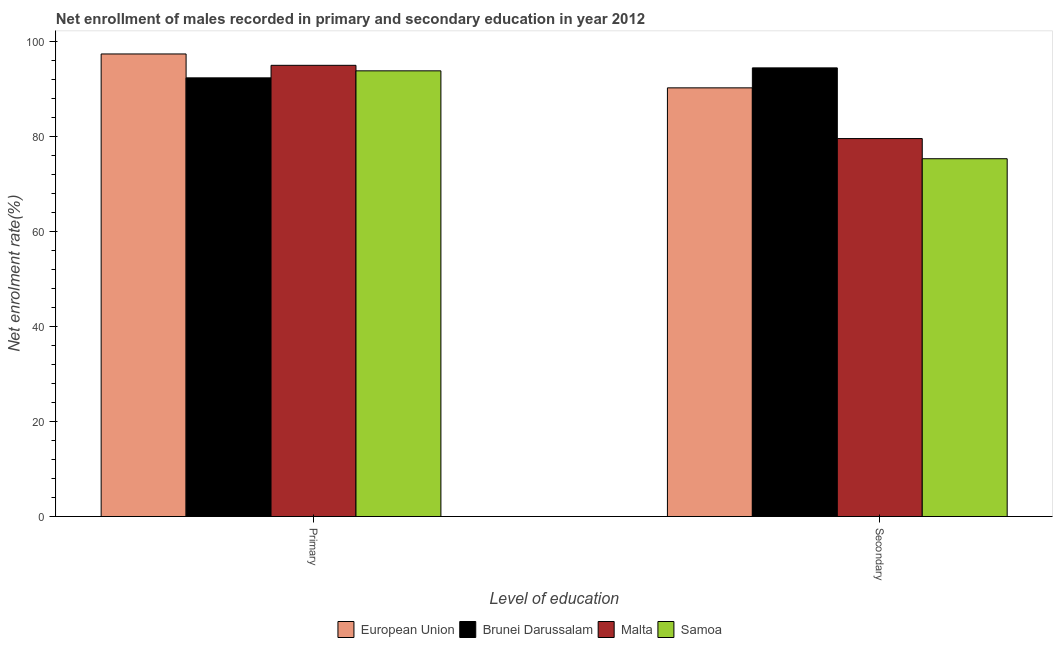How many different coloured bars are there?
Your answer should be compact. 4. How many groups of bars are there?
Your answer should be very brief. 2. Are the number of bars on each tick of the X-axis equal?
Your answer should be very brief. Yes. What is the label of the 2nd group of bars from the left?
Offer a terse response. Secondary. What is the enrollment rate in secondary education in European Union?
Provide a succinct answer. 90.28. Across all countries, what is the maximum enrollment rate in secondary education?
Provide a short and direct response. 94.49. Across all countries, what is the minimum enrollment rate in primary education?
Your answer should be compact. 92.39. In which country was the enrollment rate in primary education maximum?
Your answer should be very brief. European Union. In which country was the enrollment rate in primary education minimum?
Give a very brief answer. Brunei Darussalam. What is the total enrollment rate in primary education in the graph?
Ensure brevity in your answer.  378.71. What is the difference between the enrollment rate in primary education in Samoa and that in Malta?
Make the answer very short. -1.16. What is the difference between the enrollment rate in secondary education in Malta and the enrollment rate in primary education in Samoa?
Make the answer very short. -14.27. What is the average enrollment rate in primary education per country?
Your answer should be very brief. 94.68. What is the difference between the enrollment rate in primary education and enrollment rate in secondary education in Brunei Darussalam?
Ensure brevity in your answer.  -2.1. In how many countries, is the enrollment rate in primary education greater than 60 %?
Keep it short and to the point. 4. What is the ratio of the enrollment rate in secondary education in Samoa to that in Malta?
Keep it short and to the point. 0.95. Is the enrollment rate in primary education in European Union less than that in Malta?
Your answer should be compact. No. In how many countries, is the enrollment rate in secondary education greater than the average enrollment rate in secondary education taken over all countries?
Offer a very short reply. 2. What is the difference between two consecutive major ticks on the Y-axis?
Your answer should be compact. 20. Are the values on the major ticks of Y-axis written in scientific E-notation?
Your answer should be very brief. No. Does the graph contain grids?
Provide a succinct answer. No. What is the title of the graph?
Give a very brief answer. Net enrollment of males recorded in primary and secondary education in year 2012. What is the label or title of the X-axis?
Offer a terse response. Level of education. What is the label or title of the Y-axis?
Keep it short and to the point. Net enrolment rate(%). What is the Net enrolment rate(%) of European Union in Primary?
Keep it short and to the point. 97.42. What is the Net enrolment rate(%) in Brunei Darussalam in Primary?
Ensure brevity in your answer.  92.39. What is the Net enrolment rate(%) in Malta in Primary?
Offer a very short reply. 95.03. What is the Net enrolment rate(%) in Samoa in Primary?
Provide a succinct answer. 93.87. What is the Net enrolment rate(%) in European Union in Secondary?
Offer a very short reply. 90.28. What is the Net enrolment rate(%) of Brunei Darussalam in Secondary?
Your answer should be compact. 94.49. What is the Net enrolment rate(%) in Malta in Secondary?
Your answer should be compact. 79.6. What is the Net enrolment rate(%) in Samoa in Secondary?
Offer a very short reply. 75.36. Across all Level of education, what is the maximum Net enrolment rate(%) in European Union?
Provide a succinct answer. 97.42. Across all Level of education, what is the maximum Net enrolment rate(%) in Brunei Darussalam?
Keep it short and to the point. 94.49. Across all Level of education, what is the maximum Net enrolment rate(%) of Malta?
Provide a short and direct response. 95.03. Across all Level of education, what is the maximum Net enrolment rate(%) of Samoa?
Your response must be concise. 93.87. Across all Level of education, what is the minimum Net enrolment rate(%) in European Union?
Give a very brief answer. 90.28. Across all Level of education, what is the minimum Net enrolment rate(%) of Brunei Darussalam?
Make the answer very short. 92.39. Across all Level of education, what is the minimum Net enrolment rate(%) of Malta?
Provide a succinct answer. 79.6. Across all Level of education, what is the minimum Net enrolment rate(%) of Samoa?
Offer a very short reply. 75.36. What is the total Net enrolment rate(%) in European Union in the graph?
Keep it short and to the point. 187.71. What is the total Net enrolment rate(%) of Brunei Darussalam in the graph?
Your answer should be compact. 186.88. What is the total Net enrolment rate(%) in Malta in the graph?
Ensure brevity in your answer.  174.63. What is the total Net enrolment rate(%) in Samoa in the graph?
Your answer should be compact. 169.22. What is the difference between the Net enrolment rate(%) of European Union in Primary and that in Secondary?
Keep it short and to the point. 7.14. What is the difference between the Net enrolment rate(%) of Brunei Darussalam in Primary and that in Secondary?
Offer a terse response. -2.1. What is the difference between the Net enrolment rate(%) in Malta in Primary and that in Secondary?
Give a very brief answer. 15.43. What is the difference between the Net enrolment rate(%) of Samoa in Primary and that in Secondary?
Provide a short and direct response. 18.51. What is the difference between the Net enrolment rate(%) in European Union in Primary and the Net enrolment rate(%) in Brunei Darussalam in Secondary?
Provide a succinct answer. 2.93. What is the difference between the Net enrolment rate(%) in European Union in Primary and the Net enrolment rate(%) in Malta in Secondary?
Make the answer very short. 17.82. What is the difference between the Net enrolment rate(%) in European Union in Primary and the Net enrolment rate(%) in Samoa in Secondary?
Ensure brevity in your answer.  22.07. What is the difference between the Net enrolment rate(%) of Brunei Darussalam in Primary and the Net enrolment rate(%) of Malta in Secondary?
Offer a terse response. 12.79. What is the difference between the Net enrolment rate(%) of Brunei Darussalam in Primary and the Net enrolment rate(%) of Samoa in Secondary?
Your response must be concise. 17.03. What is the difference between the Net enrolment rate(%) in Malta in Primary and the Net enrolment rate(%) in Samoa in Secondary?
Your answer should be compact. 19.67. What is the average Net enrolment rate(%) in European Union per Level of education?
Provide a succinct answer. 93.85. What is the average Net enrolment rate(%) of Brunei Darussalam per Level of education?
Your answer should be compact. 93.44. What is the average Net enrolment rate(%) of Malta per Level of education?
Make the answer very short. 87.32. What is the average Net enrolment rate(%) in Samoa per Level of education?
Your answer should be compact. 84.61. What is the difference between the Net enrolment rate(%) of European Union and Net enrolment rate(%) of Brunei Darussalam in Primary?
Give a very brief answer. 5.03. What is the difference between the Net enrolment rate(%) in European Union and Net enrolment rate(%) in Malta in Primary?
Offer a terse response. 2.39. What is the difference between the Net enrolment rate(%) of European Union and Net enrolment rate(%) of Samoa in Primary?
Ensure brevity in your answer.  3.56. What is the difference between the Net enrolment rate(%) of Brunei Darussalam and Net enrolment rate(%) of Malta in Primary?
Make the answer very short. -2.64. What is the difference between the Net enrolment rate(%) of Brunei Darussalam and Net enrolment rate(%) of Samoa in Primary?
Provide a succinct answer. -1.48. What is the difference between the Net enrolment rate(%) in Malta and Net enrolment rate(%) in Samoa in Primary?
Ensure brevity in your answer.  1.16. What is the difference between the Net enrolment rate(%) in European Union and Net enrolment rate(%) in Brunei Darussalam in Secondary?
Your response must be concise. -4.21. What is the difference between the Net enrolment rate(%) in European Union and Net enrolment rate(%) in Malta in Secondary?
Keep it short and to the point. 10.68. What is the difference between the Net enrolment rate(%) of European Union and Net enrolment rate(%) of Samoa in Secondary?
Your answer should be compact. 14.93. What is the difference between the Net enrolment rate(%) in Brunei Darussalam and Net enrolment rate(%) in Malta in Secondary?
Your answer should be compact. 14.89. What is the difference between the Net enrolment rate(%) in Brunei Darussalam and Net enrolment rate(%) in Samoa in Secondary?
Provide a short and direct response. 19.13. What is the difference between the Net enrolment rate(%) in Malta and Net enrolment rate(%) in Samoa in Secondary?
Your answer should be very brief. 4.25. What is the ratio of the Net enrolment rate(%) of European Union in Primary to that in Secondary?
Provide a short and direct response. 1.08. What is the ratio of the Net enrolment rate(%) of Brunei Darussalam in Primary to that in Secondary?
Ensure brevity in your answer.  0.98. What is the ratio of the Net enrolment rate(%) in Malta in Primary to that in Secondary?
Your answer should be very brief. 1.19. What is the ratio of the Net enrolment rate(%) of Samoa in Primary to that in Secondary?
Ensure brevity in your answer.  1.25. What is the difference between the highest and the second highest Net enrolment rate(%) in European Union?
Provide a succinct answer. 7.14. What is the difference between the highest and the second highest Net enrolment rate(%) of Brunei Darussalam?
Ensure brevity in your answer.  2.1. What is the difference between the highest and the second highest Net enrolment rate(%) of Malta?
Your response must be concise. 15.43. What is the difference between the highest and the second highest Net enrolment rate(%) in Samoa?
Ensure brevity in your answer.  18.51. What is the difference between the highest and the lowest Net enrolment rate(%) in European Union?
Your answer should be compact. 7.14. What is the difference between the highest and the lowest Net enrolment rate(%) of Brunei Darussalam?
Offer a very short reply. 2.1. What is the difference between the highest and the lowest Net enrolment rate(%) in Malta?
Offer a very short reply. 15.43. What is the difference between the highest and the lowest Net enrolment rate(%) of Samoa?
Your answer should be compact. 18.51. 